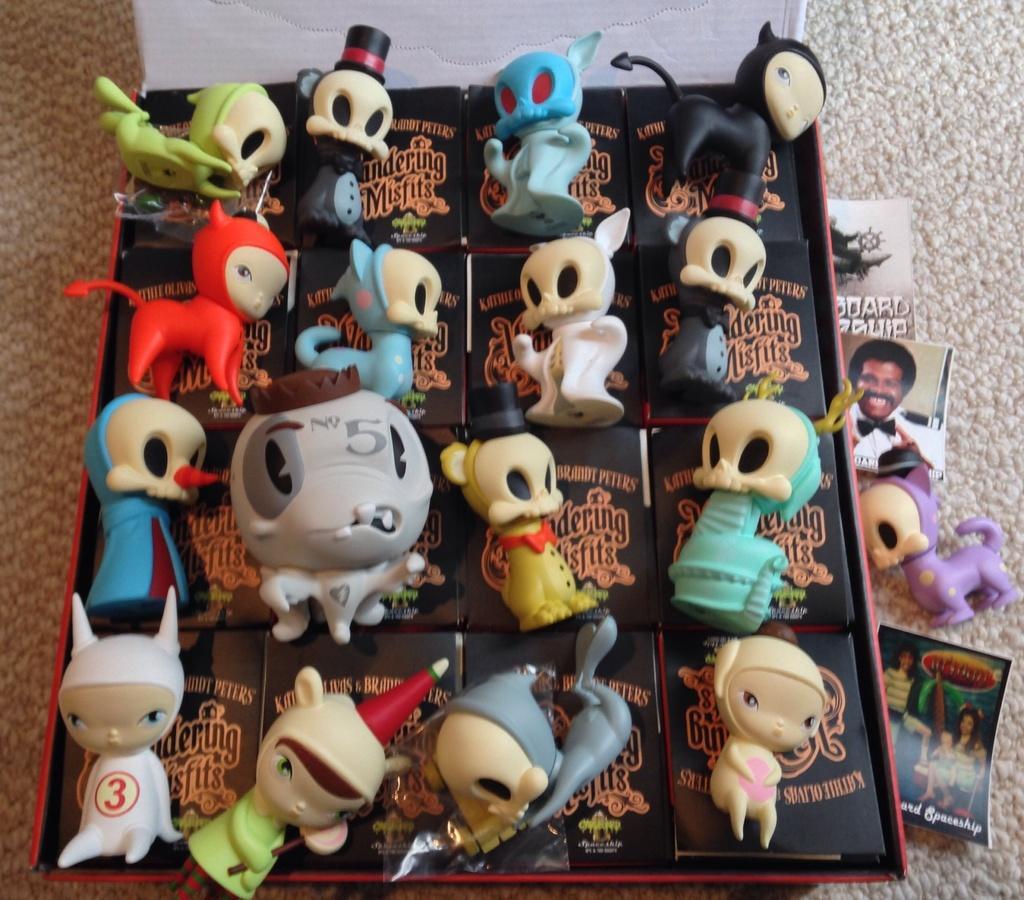Describe this image in one or two sentences. There is a box. Inside the box there are many toys. Near to the box there are some papers. 